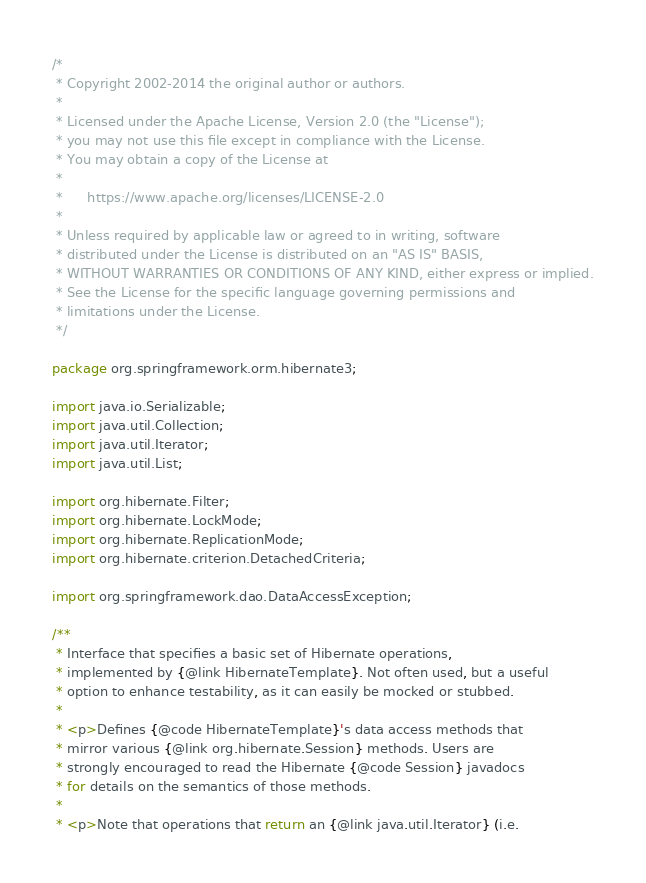<code> <loc_0><loc_0><loc_500><loc_500><_Java_>/*
 * Copyright 2002-2014 the original author or authors.
 *
 * Licensed under the Apache License, Version 2.0 (the "License");
 * you may not use this file except in compliance with the License.
 * You may obtain a copy of the License at
 *
 *      https://www.apache.org/licenses/LICENSE-2.0
 *
 * Unless required by applicable law or agreed to in writing, software
 * distributed under the License is distributed on an "AS IS" BASIS,
 * WITHOUT WARRANTIES OR CONDITIONS OF ANY KIND, either express or implied.
 * See the License for the specific language governing permissions and
 * limitations under the License.
 */

package org.springframework.orm.hibernate3;

import java.io.Serializable;
import java.util.Collection;
import java.util.Iterator;
import java.util.List;

import org.hibernate.Filter;
import org.hibernate.LockMode;
import org.hibernate.ReplicationMode;
import org.hibernate.criterion.DetachedCriteria;

import org.springframework.dao.DataAccessException;

/**
 * Interface that specifies a basic set of Hibernate operations,
 * implemented by {@link HibernateTemplate}. Not often used, but a useful
 * option to enhance testability, as it can easily be mocked or stubbed.
 *
 * <p>Defines {@code HibernateTemplate}'s data access methods that
 * mirror various {@link org.hibernate.Session} methods. Users are
 * strongly encouraged to read the Hibernate {@code Session} javadocs
 * for details on the semantics of those methods.
 *
 * <p>Note that operations that return an {@link java.util.Iterator} (i.e.</code> 